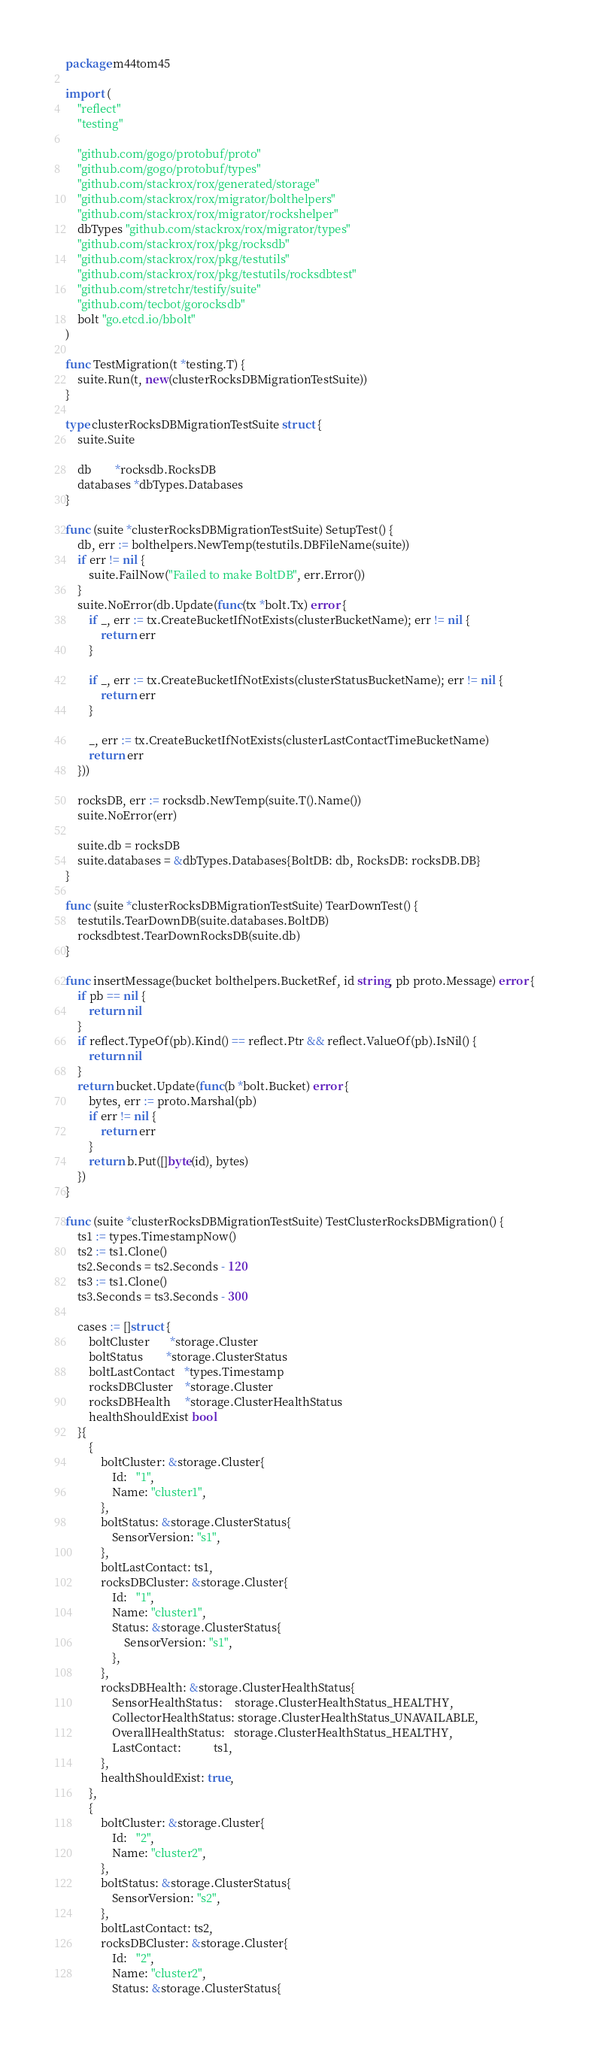<code> <loc_0><loc_0><loc_500><loc_500><_Go_>package m44tom45

import (
	"reflect"
	"testing"

	"github.com/gogo/protobuf/proto"
	"github.com/gogo/protobuf/types"
	"github.com/stackrox/rox/generated/storage"
	"github.com/stackrox/rox/migrator/bolthelpers"
	"github.com/stackrox/rox/migrator/rockshelper"
	dbTypes "github.com/stackrox/rox/migrator/types"
	"github.com/stackrox/rox/pkg/rocksdb"
	"github.com/stackrox/rox/pkg/testutils"
	"github.com/stackrox/rox/pkg/testutils/rocksdbtest"
	"github.com/stretchr/testify/suite"
	"github.com/tecbot/gorocksdb"
	bolt "go.etcd.io/bbolt"
)

func TestMigration(t *testing.T) {
	suite.Run(t, new(clusterRocksDBMigrationTestSuite))
}

type clusterRocksDBMigrationTestSuite struct {
	suite.Suite

	db        *rocksdb.RocksDB
	databases *dbTypes.Databases
}

func (suite *clusterRocksDBMigrationTestSuite) SetupTest() {
	db, err := bolthelpers.NewTemp(testutils.DBFileName(suite))
	if err != nil {
		suite.FailNow("Failed to make BoltDB", err.Error())
	}
	suite.NoError(db.Update(func(tx *bolt.Tx) error {
		if _, err := tx.CreateBucketIfNotExists(clusterBucketName); err != nil {
			return err
		}

		if _, err := tx.CreateBucketIfNotExists(clusterStatusBucketName); err != nil {
			return err
		}

		_, err := tx.CreateBucketIfNotExists(clusterLastContactTimeBucketName)
		return err
	}))

	rocksDB, err := rocksdb.NewTemp(suite.T().Name())
	suite.NoError(err)

	suite.db = rocksDB
	suite.databases = &dbTypes.Databases{BoltDB: db, RocksDB: rocksDB.DB}
}

func (suite *clusterRocksDBMigrationTestSuite) TearDownTest() {
	testutils.TearDownDB(suite.databases.BoltDB)
	rocksdbtest.TearDownRocksDB(suite.db)
}

func insertMessage(bucket bolthelpers.BucketRef, id string, pb proto.Message) error {
	if pb == nil {
		return nil
	}
	if reflect.TypeOf(pb).Kind() == reflect.Ptr && reflect.ValueOf(pb).IsNil() {
		return nil
	}
	return bucket.Update(func(b *bolt.Bucket) error {
		bytes, err := proto.Marshal(pb)
		if err != nil {
			return err
		}
		return b.Put([]byte(id), bytes)
	})
}

func (suite *clusterRocksDBMigrationTestSuite) TestClusterRocksDBMigration() {
	ts1 := types.TimestampNow()
	ts2 := ts1.Clone()
	ts2.Seconds = ts2.Seconds - 120
	ts3 := ts1.Clone()
	ts3.Seconds = ts3.Seconds - 300

	cases := []struct {
		boltCluster       *storage.Cluster
		boltStatus        *storage.ClusterStatus
		boltLastContact   *types.Timestamp
		rocksDBCluster    *storage.Cluster
		rocksDBHealth     *storage.ClusterHealthStatus
		healthShouldExist bool
	}{
		{
			boltCluster: &storage.Cluster{
				Id:   "1",
				Name: "cluster1",
			},
			boltStatus: &storage.ClusterStatus{
				SensorVersion: "s1",
			},
			boltLastContact: ts1,
			rocksDBCluster: &storage.Cluster{
				Id:   "1",
				Name: "cluster1",
				Status: &storage.ClusterStatus{
					SensorVersion: "s1",
				},
			},
			rocksDBHealth: &storage.ClusterHealthStatus{
				SensorHealthStatus:    storage.ClusterHealthStatus_HEALTHY,
				CollectorHealthStatus: storage.ClusterHealthStatus_UNAVAILABLE,
				OverallHealthStatus:   storage.ClusterHealthStatus_HEALTHY,
				LastContact:           ts1,
			},
			healthShouldExist: true,
		},
		{
			boltCluster: &storage.Cluster{
				Id:   "2",
				Name: "cluster2",
			},
			boltStatus: &storage.ClusterStatus{
				SensorVersion: "s2",
			},
			boltLastContact: ts2,
			rocksDBCluster: &storage.Cluster{
				Id:   "2",
				Name: "cluster2",
				Status: &storage.ClusterStatus{</code> 